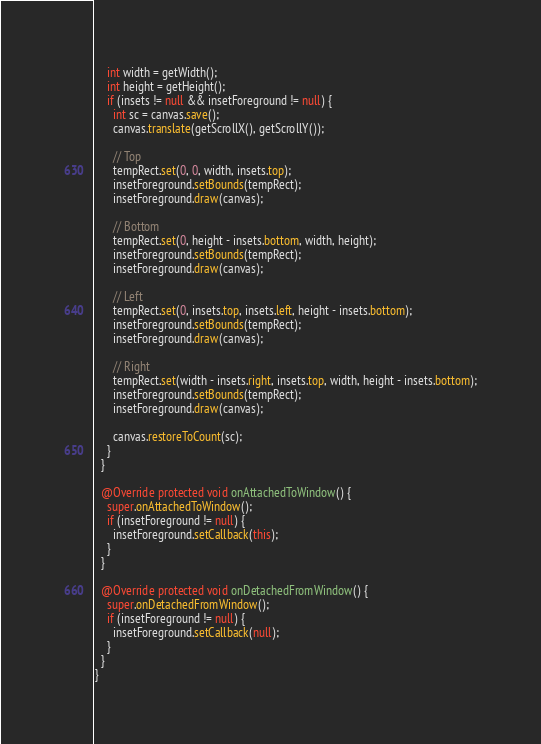<code> <loc_0><loc_0><loc_500><loc_500><_Java_>    int width = getWidth();
    int height = getHeight();
    if (insets != null && insetForeground != null) {
      int sc = canvas.save();
      canvas.translate(getScrollX(), getScrollY());

      // Top
      tempRect.set(0, 0, width, insets.top);
      insetForeground.setBounds(tempRect);
      insetForeground.draw(canvas);

      // Bottom
      tempRect.set(0, height - insets.bottom, width, height);
      insetForeground.setBounds(tempRect);
      insetForeground.draw(canvas);

      // Left
      tempRect.set(0, insets.top, insets.left, height - insets.bottom);
      insetForeground.setBounds(tempRect);
      insetForeground.draw(canvas);

      // Right
      tempRect.set(width - insets.right, insets.top, width, height - insets.bottom);
      insetForeground.setBounds(tempRect);
      insetForeground.draw(canvas);

      canvas.restoreToCount(sc);
    }
  }

  @Override protected void onAttachedToWindow() {
    super.onAttachedToWindow();
    if (insetForeground != null) {
      insetForeground.setCallback(this);
    }
  }

  @Override protected void onDetachedFromWindow() {
    super.onDetachedFromWindow();
    if (insetForeground != null) {
      insetForeground.setCallback(null);
    }
  }
}
</code> 